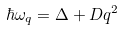Convert formula to latex. <formula><loc_0><loc_0><loc_500><loc_500>\hbar { \omega } _ { q } = \Delta + D q ^ { 2 }</formula> 